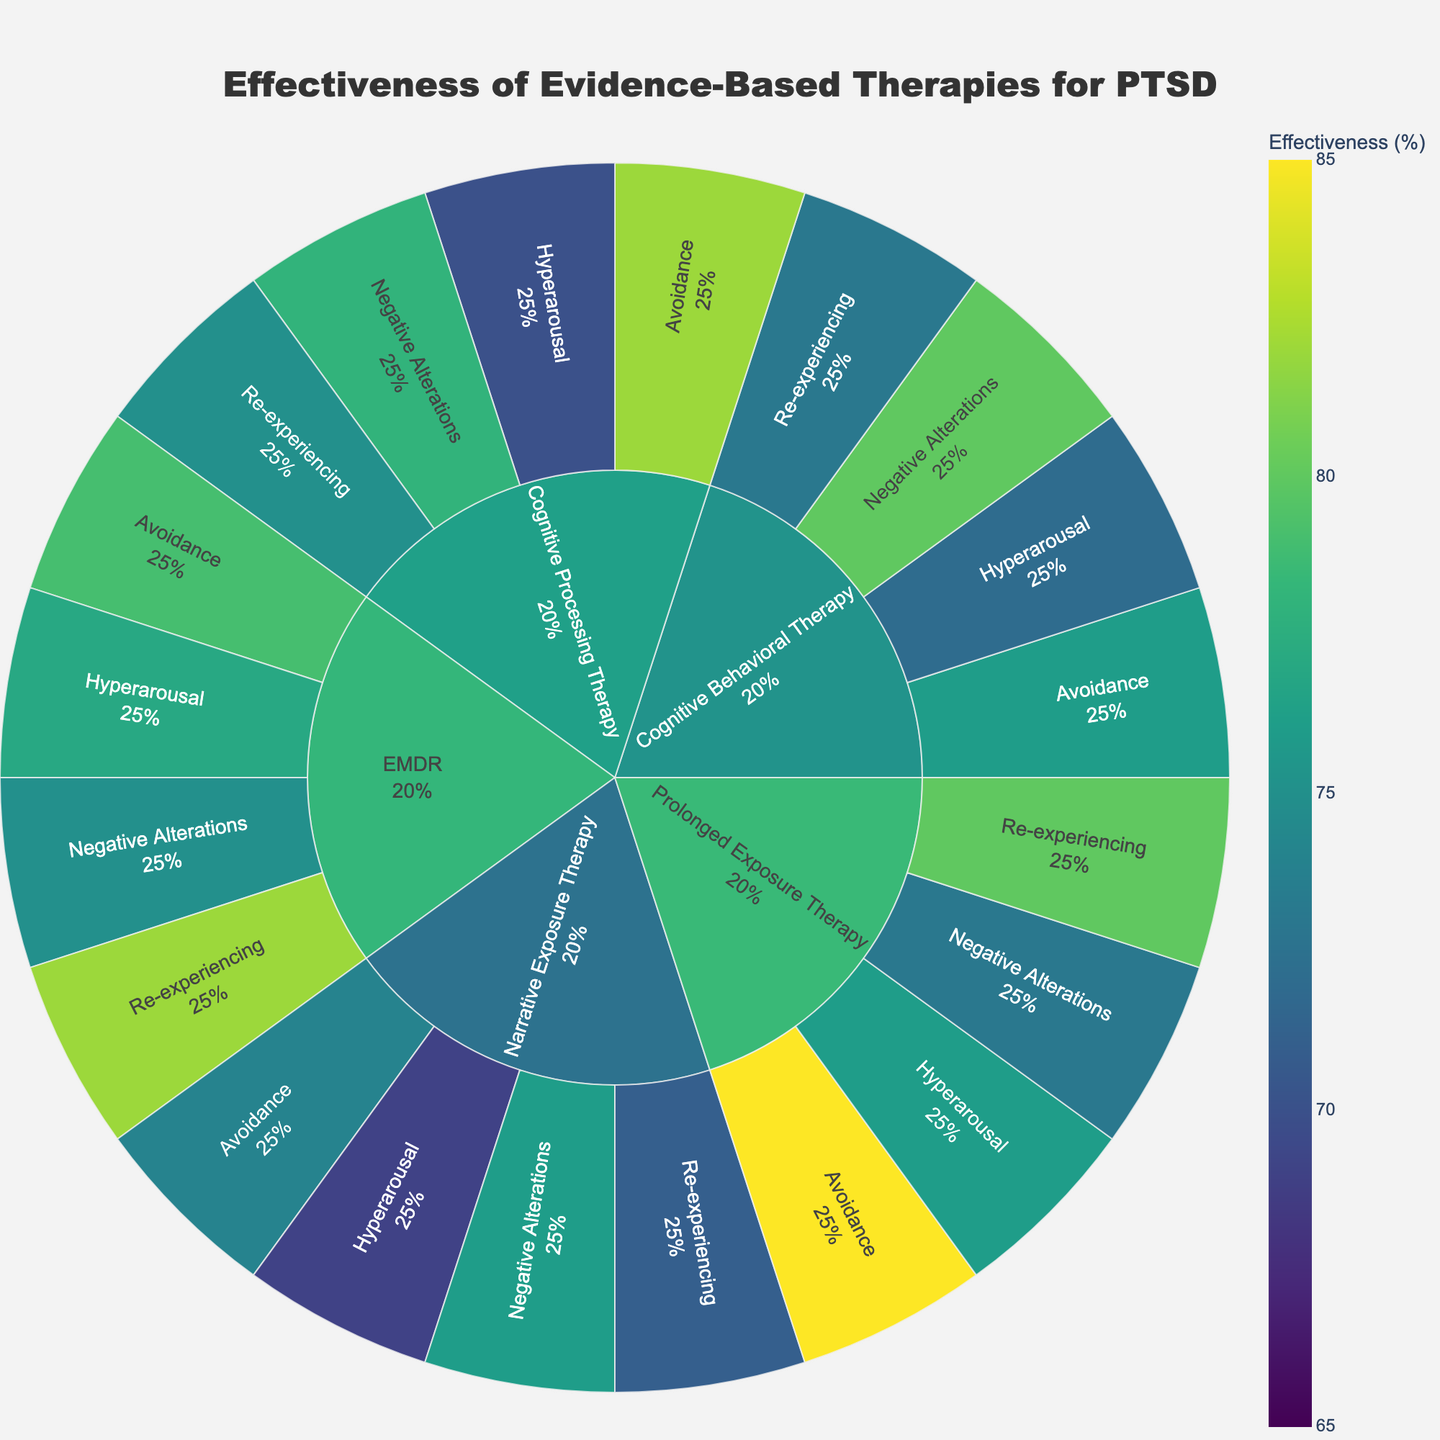What is the effectiveness of Prolonged Exposure Therapy for the avoidance symptom cluster? Look for Prolonged Exposure Therapy in the Sunburst Plot and locate the segment for avoidance symptom cluster to find the effectiveness.
Answer: 85% How does the effectiveness of Cognitive Processing Therapy for re-experiencing symptoms compare to that of EMDR for the same symptoms? Identify the effectiveness of Cognitive Processing Therapy for re-experiencing (75%) and then compare it to the effectiveness of EMDR for re-experiencing (82%).
Answer: EMDR is higher Which therapy type has the highest effectiveness for hyperarousal symptoms? Look for all segment values related to hyperarousal symptoms and compare their effectiveness.
Answer: EMDR What is the average effectiveness of Cognitive Behavioral Therapy across all symptom clusters? Sum the effectiveness percentages of Cognitive Behavioral Therapy (73%, 76%, 80%, 72%) and divide by the number of symptom clusters (4). Calculation: (73+76+80+72)/4 = 75.25
Answer: 75.25% What is the overall range of effectiveness values represented in the figure? Identify the minimum and maximum effectiveness values across all therapy types and symptom clusters. The minimum is 69% (Narrative Exposure Therapy for Hyperarousal) and maximum is 85% (Prolonged Exposure Therapy for Avoidance).
Answer: 69%-85% Which symptom cluster shows the highest average effectiveness across all therapies? Calculate the average effectiveness for each symptom cluster by summing the effectiveness percentages and dividing by the number of therapy types. Re-experiencing: (75+80+82+73+71)/5 = 76.2; Avoidance: (82+85+79+76+74)/5 = 79.2; Negative Alterations: (78+73+75+80+76)/5 = 76.4; Hyperarousal: (70+76+77+72+69)/5 = 72.8.
Answer: Avoidance How many therapy types are represented in the plot? Count the unique therapy types indicated at the root of the Sunburst Plot.
Answer: 5 For Prolonged Exposure Therapy, which symptom cluster has the lowest effectiveness? Look at all segment values within Prolonged Exposure Therapy and identify the lowest effectiveness.
Answer: Negative Alterations What percentage of the total therapies does EMDR represent in the Sunburst Plot? Since each therapy type has 4 symptom clusters (equal segments), calculate the number of segments represented by EMDR divided by the total segments (4 segments for each of 5 therapies). Calculation: 4/20 = 0.20, then convert 0.20 to percentage.
Answer: 20% What is the difference in effectiveness between the highest and lowest therapy for avoidance symptoms? Identify the highest effectiveness for avoidance symptoms (Prolonged Exposure Therapy, 85%) and the lowest (Narrative Exposure Therapy, 74%) and calculate the difference. Calculation: 85 - 74
Answer: 11 